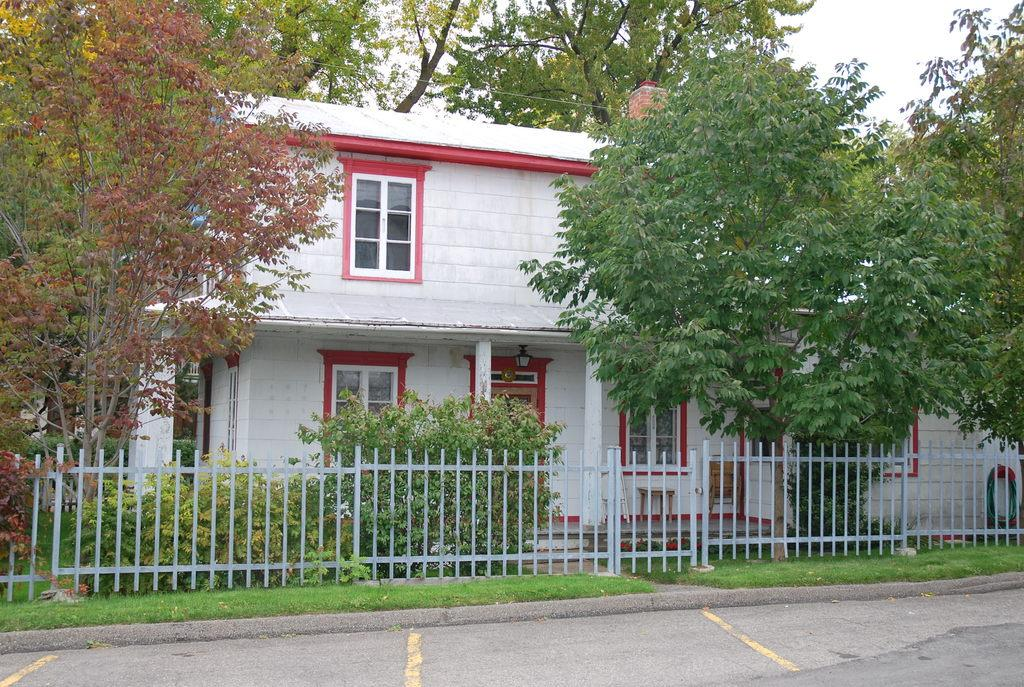What is the main structure in the center of the image? There is a building in the center of the image. What is located at the bottom of the image? There is a fence at the bottom of the image. What type of vegetation can be seen in the image? Trees are visible in the image. What is visible in the background of the image? The sky is visible in the background of the image. How many kittens are sitting on the roof of the building in the image? There are no kittens present in the image, so it is not possible to determine how many might be sitting on the roof. 